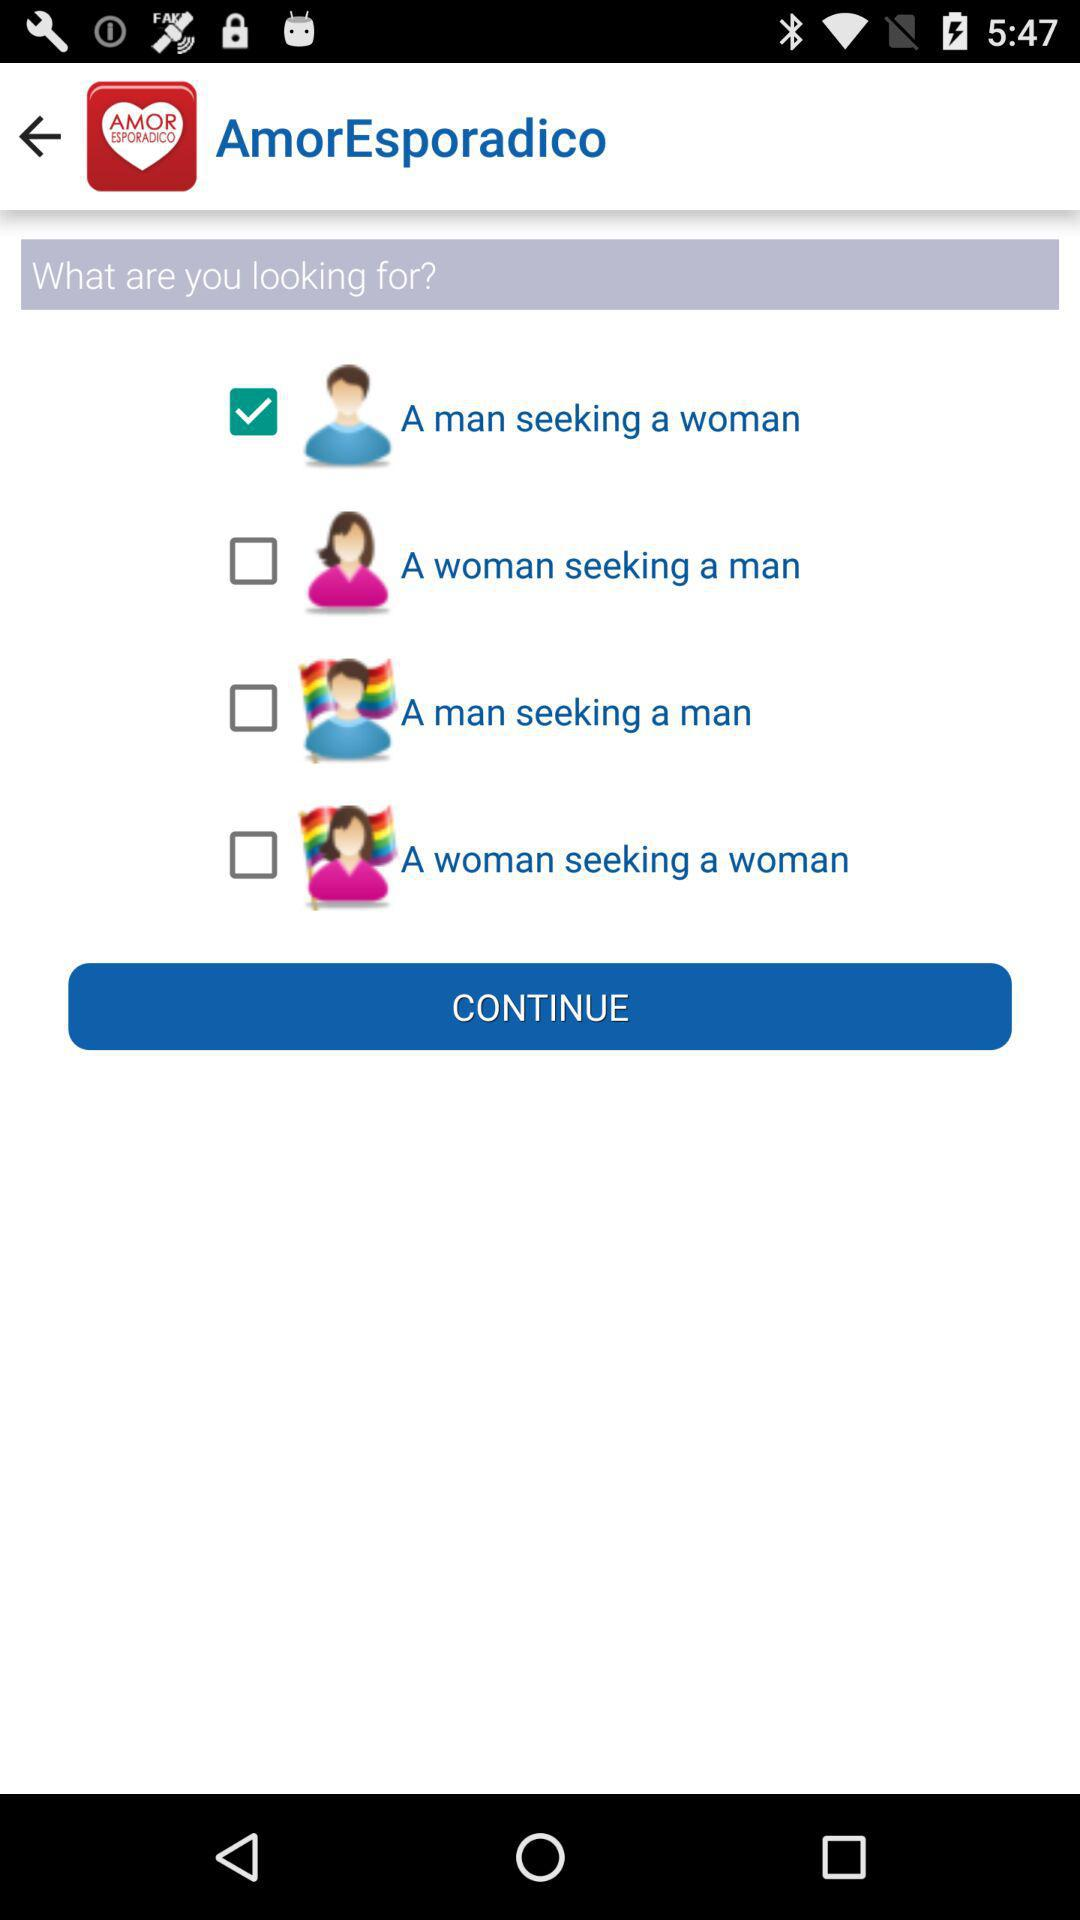How old is the user?
When the provided information is insufficient, respond with <no answer>. <no answer> 